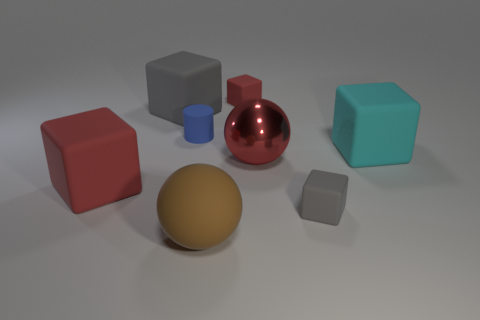Are there more tiny gray things than big red metal cylinders?
Your answer should be very brief. Yes. There is a tiny object right of the large red sphere; what number of rubber things are left of it?
Your answer should be compact. 5. How many objects are either big cubes that are left of the brown ball or small gray matte objects?
Give a very brief answer. 3. Are there any other things of the same shape as the large red rubber thing?
Offer a very short reply. Yes. What is the shape of the big red object left of the big matte block behind the cyan matte object?
Provide a short and direct response. Cube. How many cubes are big red rubber objects or brown objects?
Your response must be concise. 1. There is a tiny object in front of the cyan matte thing; is its shape the same as the red matte thing that is behind the big red matte block?
Your response must be concise. Yes. There is a rubber cube that is in front of the blue thing and left of the red metallic thing; what color is it?
Your answer should be very brief. Red. Is the color of the metal object the same as the big rubber block in front of the large cyan rubber object?
Keep it short and to the point. Yes. There is a red object that is in front of the tiny red rubber block and right of the small blue rubber cylinder; what is its size?
Offer a terse response. Large. 